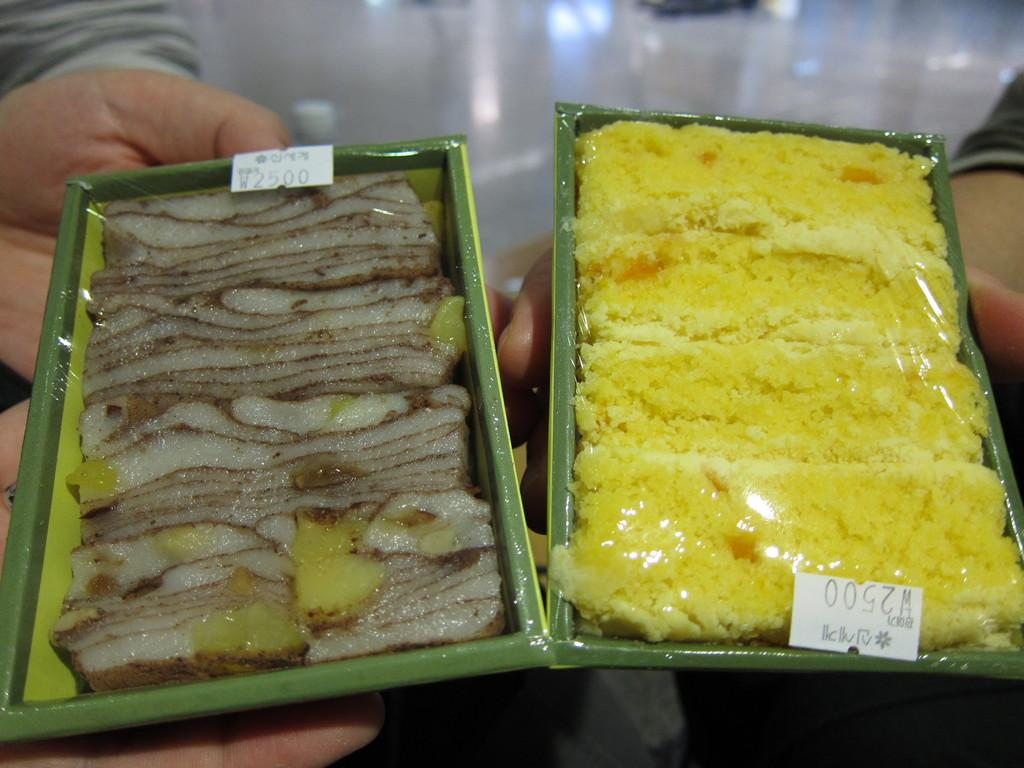How many food bowls are visible in the image? There are two rectangular food bowls in the image. What is inside the food bowls? The food bowls contain food. What can be seen on the food bowls? There are stickers on the food bowls with numbers and text. Who or what is holding the food bowls? There are hands beneath the bowls holding them. What type of furniture is advertised in the image? There is no furniture being advertised in the image; it primarily features food bowls with stickers and hands holding them. 